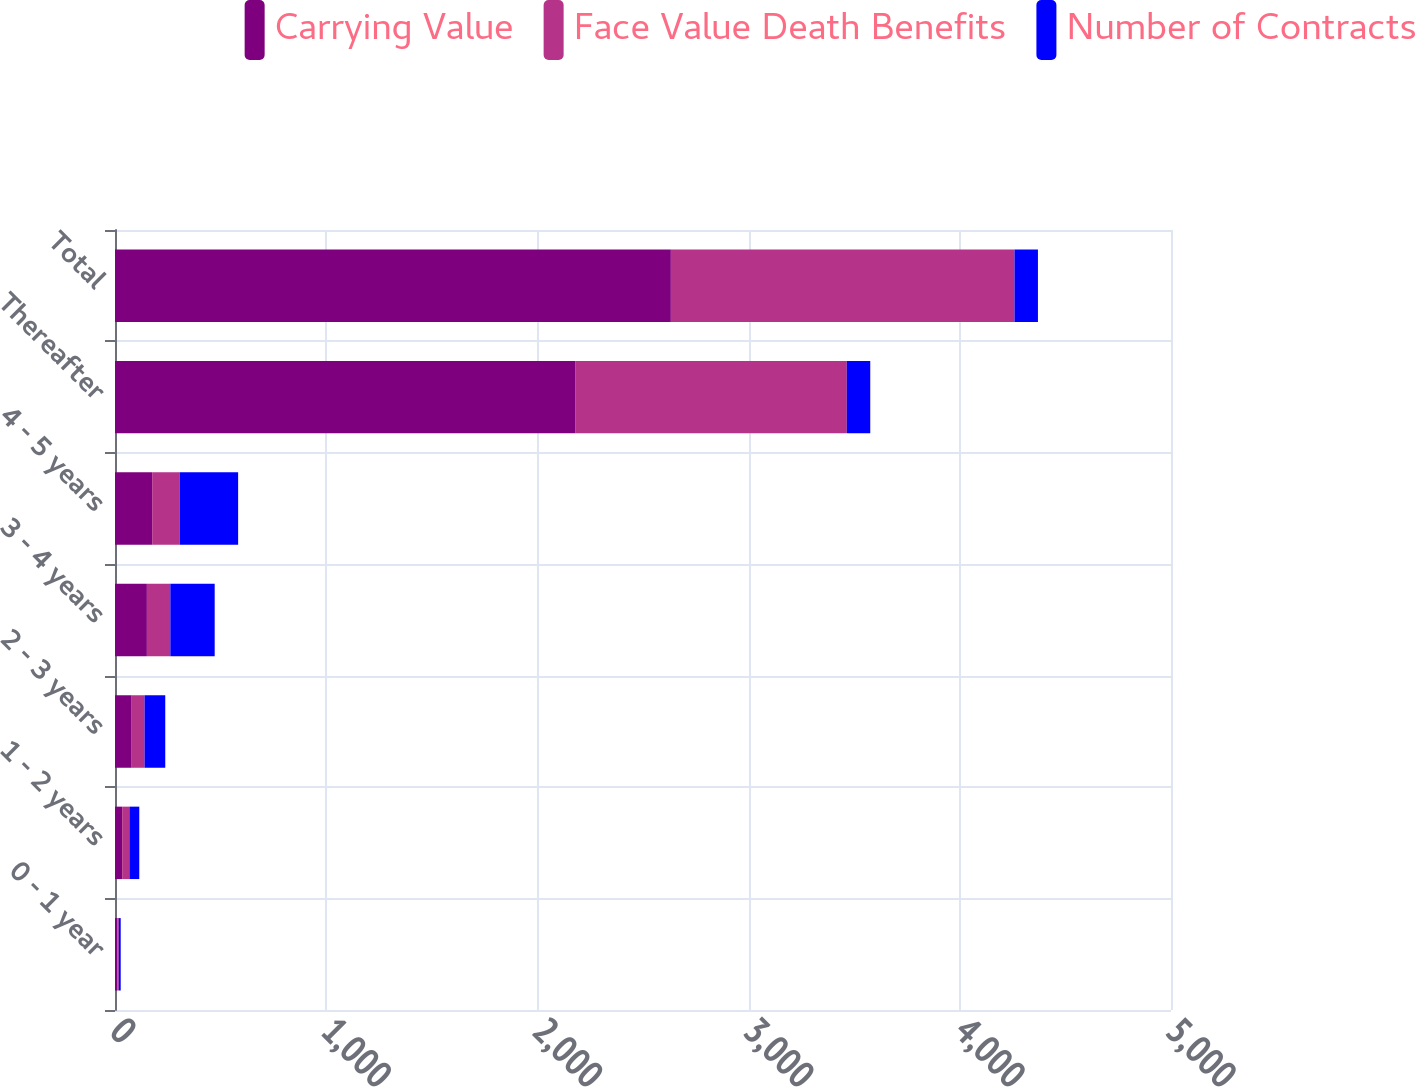Convert chart to OTSL. <chart><loc_0><loc_0><loc_500><loc_500><stacked_bar_chart><ecel><fcel>0 - 1 year<fcel>1 - 2 years<fcel>2 - 3 years<fcel>3 - 4 years<fcel>4 - 5 years<fcel>Thereafter<fcel>Total<nl><fcel>Carrying Value<fcel>11<fcel>34<fcel>79<fcel>151<fcel>176<fcel>2181<fcel>2632<nl><fcel>Face Value Death Benefits<fcel>7<fcel>34<fcel>61<fcel>111<fcel>130<fcel>1284<fcel>1627<nl><fcel>Number of Contracts<fcel>9<fcel>47<fcel>98<fcel>210<fcel>277<fcel>111<fcel>111<nl></chart> 